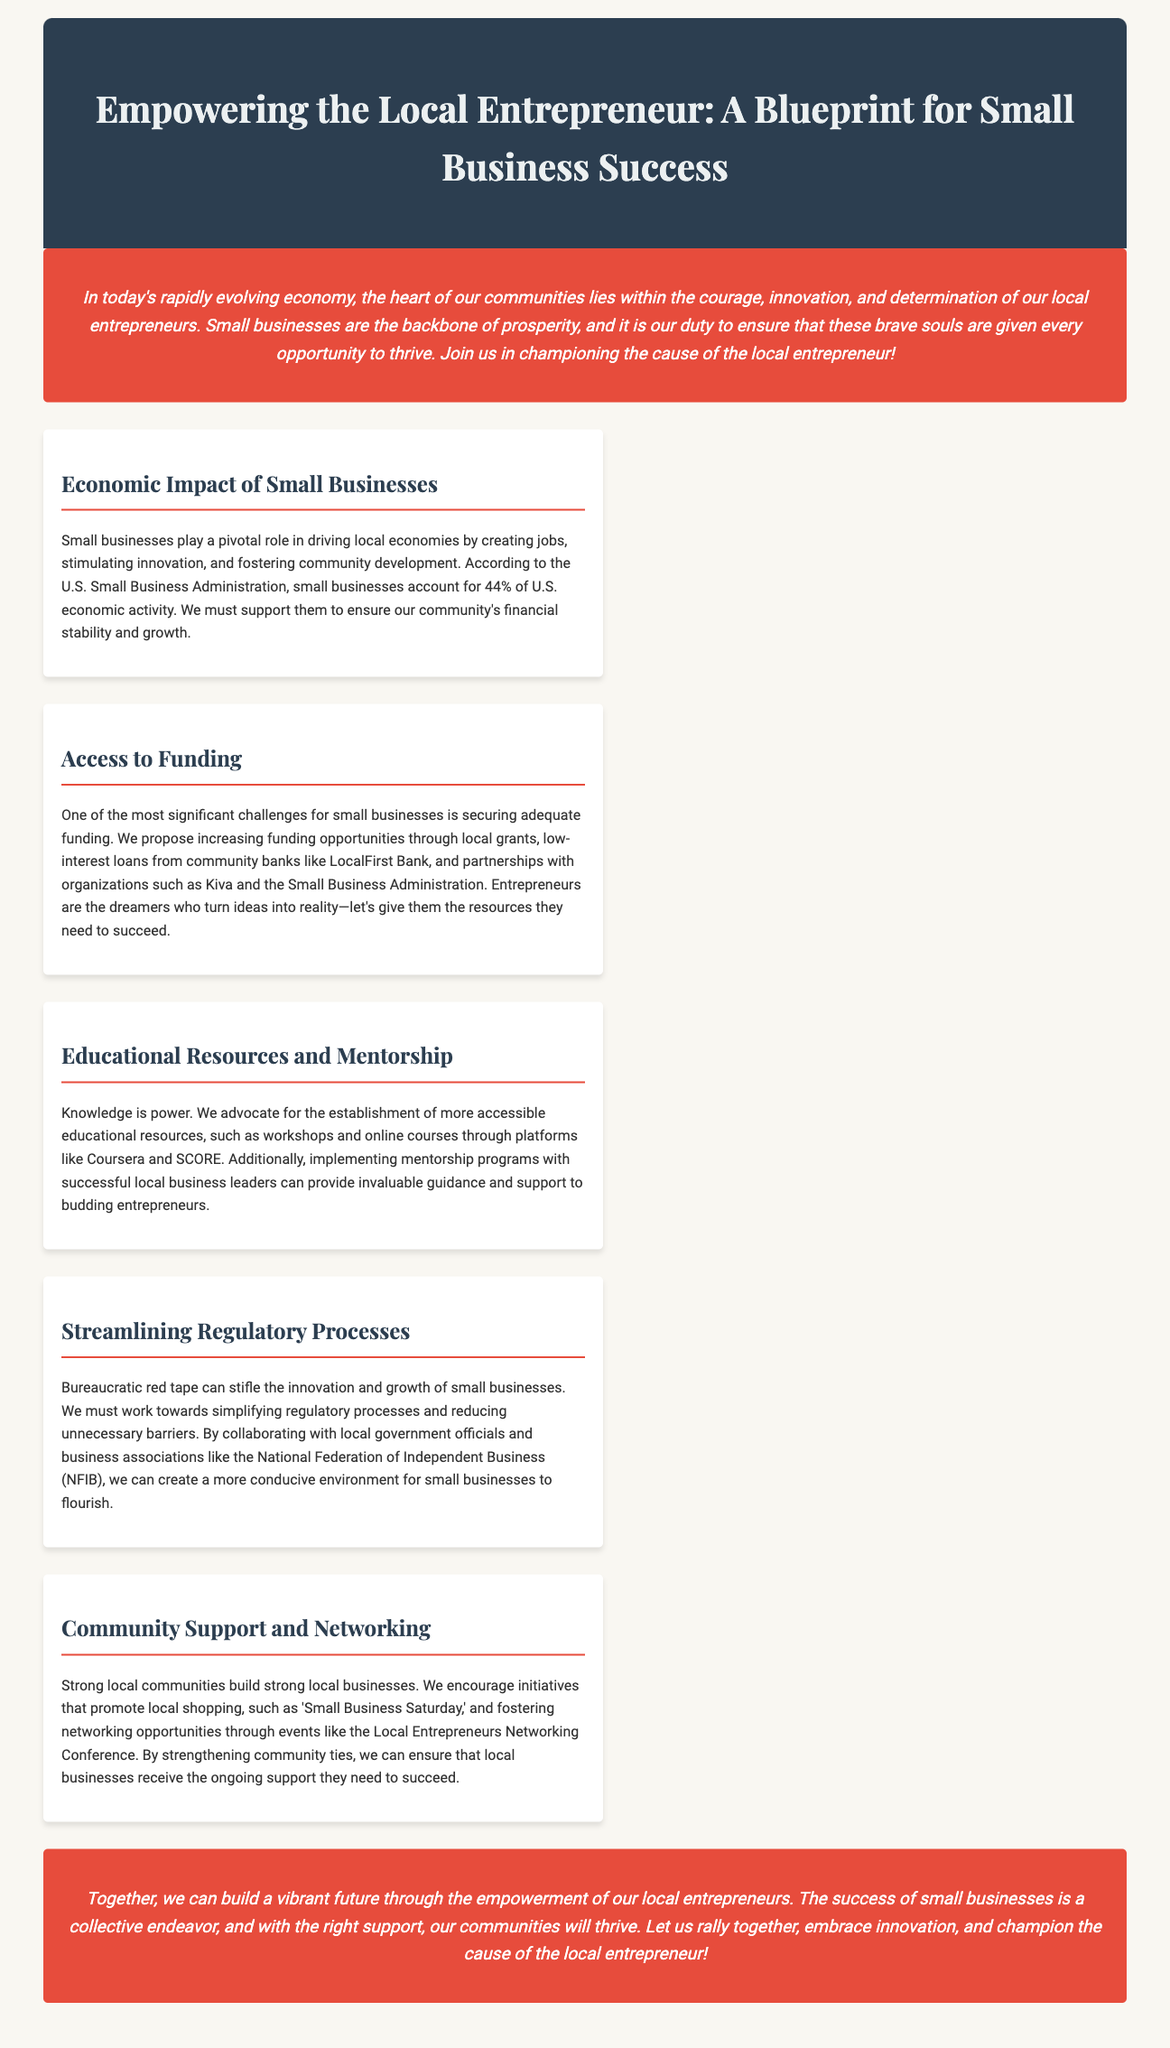What percentage of U.S. economic activity do small businesses account for? The document states that small businesses account for 44% of U.S. economic activity according to the U.S. Small Business Administration.
Answer: 44% What funding opportunities are proposed for local entrepreneurs? The document suggests increasing funding opportunities through local grants, low-interest loans, and partnerships with organizations like Kiva and the Small Business Administration.
Answer: Local grants, low-interest loans What is emphasized as essential for the success of budding entrepreneurs? The document emphasizes the importance of educational resources and mentorship for the success of budding entrepreneurs.
Answer: Educational resources and mentorship Which organization is mentioned in relation to simplifying regulatory processes? The document mentions the National Federation of Independent Business (NFIB) in relation to collaborating to simplify regulatory processes.
Answer: NFIB What event is suggested to promote local businesses? The document encourages initiatives like 'Small Business Saturday' to promote local shopping.
Answer: Small Business Saturday 